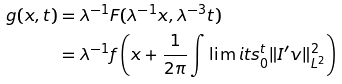<formula> <loc_0><loc_0><loc_500><loc_500>g ( x , t ) & = \lambda ^ { - 1 } F ( \lambda ^ { - 1 } x , \lambda ^ { - 3 } t ) \\ & = \lambda ^ { - 1 } f \left ( x + \frac { 1 } { 2 \pi } \int \lim i t s _ { 0 } ^ { t } \| I ^ { \prime } v \| _ { L ^ { 2 } } ^ { 2 } \right )</formula> 